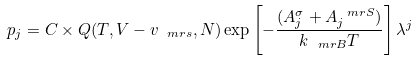<formula> <loc_0><loc_0><loc_500><loc_500>p _ { j } = C \times Q ( T , V - v _ { \ m r { s } } , N ) \exp \left [ - \frac { ( A _ { j } ^ { \sigma } + A _ { j } ^ { \ m r { S } } ) } { k _ { \ m r { B } } T } \right ] \lambda ^ { j }</formula> 